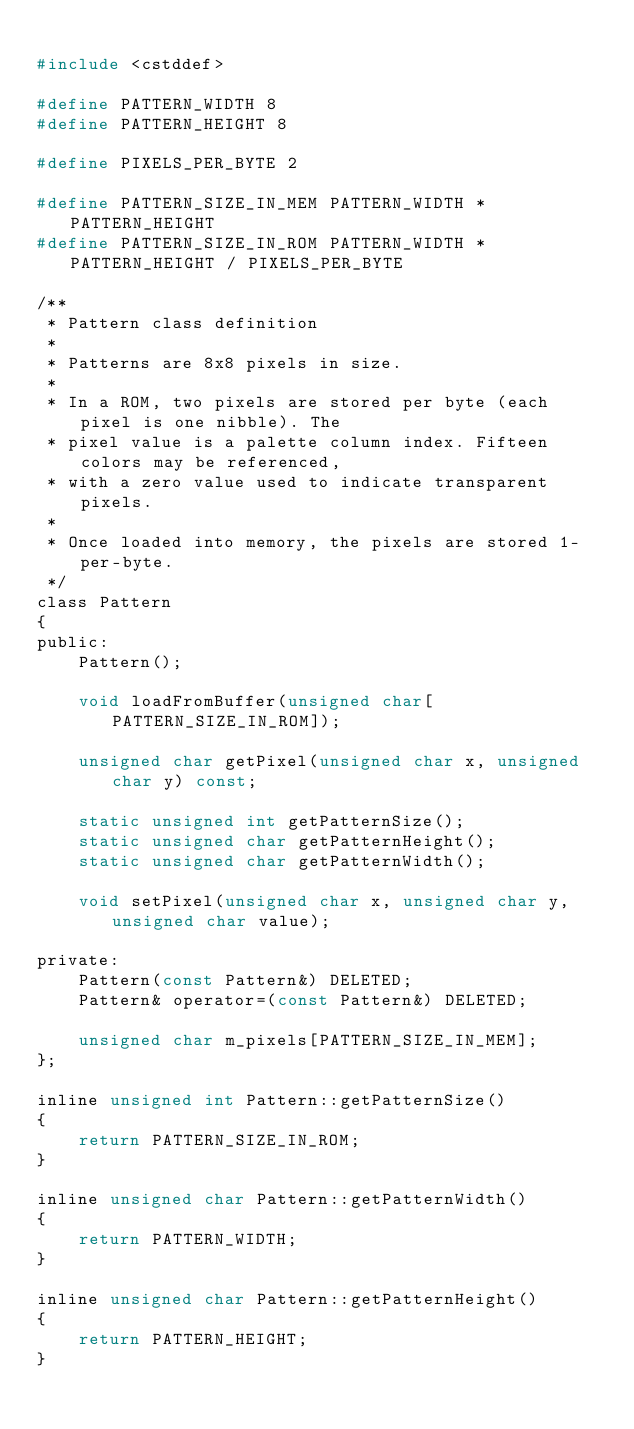Convert code to text. <code><loc_0><loc_0><loc_500><loc_500><_C_>
#include <cstddef>

#define PATTERN_WIDTH 8
#define PATTERN_HEIGHT 8

#define PIXELS_PER_BYTE 2

#define PATTERN_SIZE_IN_MEM PATTERN_WIDTH * PATTERN_HEIGHT
#define PATTERN_SIZE_IN_ROM PATTERN_WIDTH * PATTERN_HEIGHT / PIXELS_PER_BYTE

/**
 * Pattern class definition
 *
 * Patterns are 8x8 pixels in size.
 *
 * In a ROM, two pixels are stored per byte (each pixel is one nibble). The
 * pixel value is a palette column index. Fifteen colors may be referenced,
 * with a zero value used to indicate transparent pixels.
 *
 * Once loaded into memory, the pixels are stored 1-per-byte.
 */
class Pattern
{
public:
    Pattern();

    void loadFromBuffer(unsigned char[PATTERN_SIZE_IN_ROM]);

    unsigned char getPixel(unsigned char x, unsigned char y) const;

    static unsigned int getPatternSize();
    static unsigned char getPatternHeight();
    static unsigned char getPatternWidth();

    void setPixel(unsigned char x, unsigned char y, unsigned char value);

private:
    Pattern(const Pattern&) DELETED;
    Pattern& operator=(const Pattern&) DELETED;

    unsigned char m_pixels[PATTERN_SIZE_IN_MEM];
};

inline unsigned int Pattern::getPatternSize()
{
    return PATTERN_SIZE_IN_ROM;
}

inline unsigned char Pattern::getPatternWidth()
{
    return PATTERN_WIDTH;
}

inline unsigned char Pattern::getPatternHeight()
{
    return PATTERN_HEIGHT;
}
</code> 